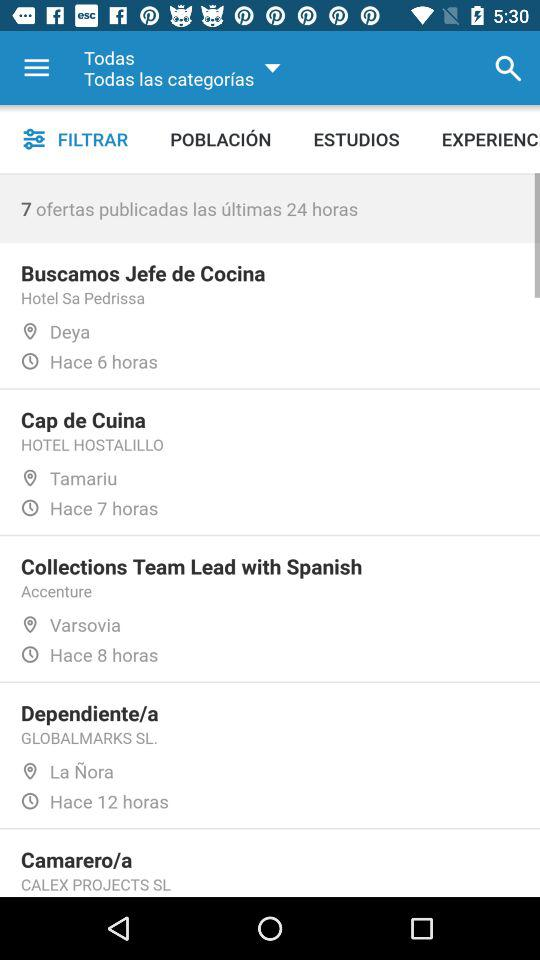How many offers have been published in the last 24 hours?
Answer the question using a single word or phrase. 7 